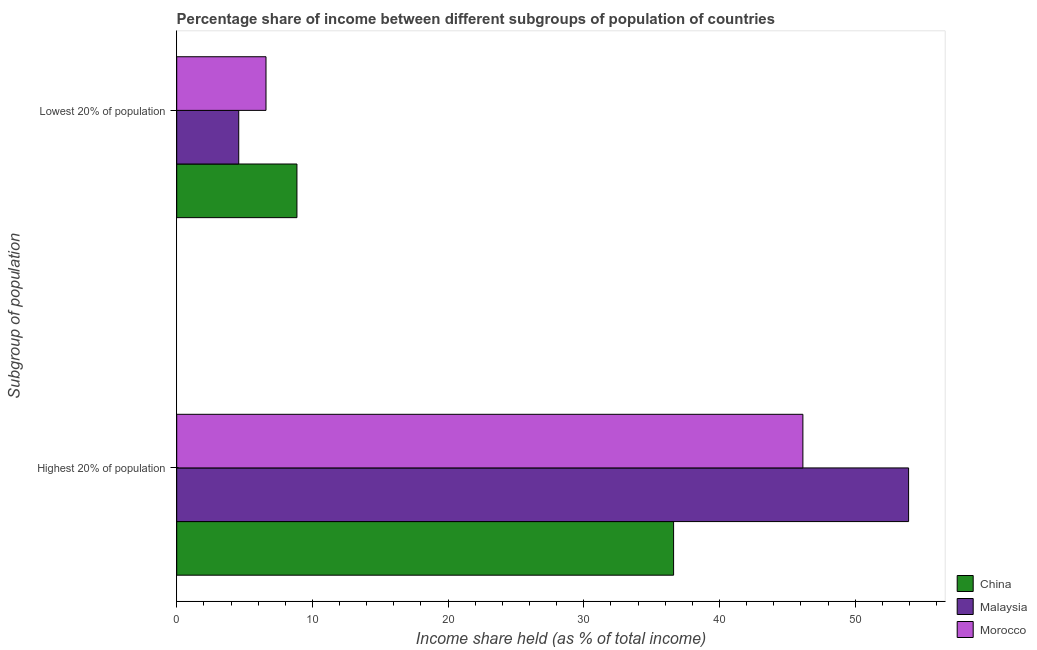Are the number of bars per tick equal to the number of legend labels?
Offer a very short reply. Yes. How many bars are there on the 1st tick from the bottom?
Give a very brief answer. 3. What is the label of the 2nd group of bars from the top?
Make the answer very short. Highest 20% of population. What is the income share held by lowest 20% of the population in China?
Offer a terse response. 8.86. Across all countries, what is the maximum income share held by lowest 20% of the population?
Ensure brevity in your answer.  8.86. Across all countries, what is the minimum income share held by lowest 20% of the population?
Your answer should be compact. 4.57. In which country was the income share held by highest 20% of the population maximum?
Provide a short and direct response. Malaysia. What is the total income share held by highest 20% of the population in the graph?
Ensure brevity in your answer.  136.71. What is the difference between the income share held by highest 20% of the population in Malaysia and that in China?
Keep it short and to the point. 17.32. What is the difference between the income share held by lowest 20% of the population in Malaysia and the income share held by highest 20% of the population in China?
Your answer should be compact. -32.05. What is the average income share held by highest 20% of the population per country?
Your answer should be very brief. 45.57. What is the difference between the income share held by lowest 20% of the population and income share held by highest 20% of the population in Malaysia?
Your answer should be compact. -49.37. In how many countries, is the income share held by lowest 20% of the population greater than 44 %?
Offer a terse response. 0. What is the ratio of the income share held by lowest 20% of the population in Morocco to that in Malaysia?
Provide a succinct answer. 1.44. Is the income share held by lowest 20% of the population in China less than that in Morocco?
Offer a terse response. No. In how many countries, is the income share held by lowest 20% of the population greater than the average income share held by lowest 20% of the population taken over all countries?
Ensure brevity in your answer.  1. What does the 2nd bar from the top in Lowest 20% of population represents?
Give a very brief answer. Malaysia. What does the 3rd bar from the bottom in Highest 20% of population represents?
Ensure brevity in your answer.  Morocco. How many bars are there?
Make the answer very short. 6. Are all the bars in the graph horizontal?
Ensure brevity in your answer.  Yes. How many countries are there in the graph?
Offer a very short reply. 3. Are the values on the major ticks of X-axis written in scientific E-notation?
Your answer should be compact. No. Does the graph contain grids?
Keep it short and to the point. No. What is the title of the graph?
Offer a very short reply. Percentage share of income between different subgroups of population of countries. Does "Grenada" appear as one of the legend labels in the graph?
Offer a very short reply. No. What is the label or title of the X-axis?
Provide a succinct answer. Income share held (as % of total income). What is the label or title of the Y-axis?
Keep it short and to the point. Subgroup of population. What is the Income share held (as % of total income) of China in Highest 20% of population?
Your response must be concise. 36.62. What is the Income share held (as % of total income) of Malaysia in Highest 20% of population?
Offer a very short reply. 53.94. What is the Income share held (as % of total income) in Morocco in Highest 20% of population?
Offer a very short reply. 46.15. What is the Income share held (as % of total income) of China in Lowest 20% of population?
Ensure brevity in your answer.  8.86. What is the Income share held (as % of total income) of Malaysia in Lowest 20% of population?
Provide a short and direct response. 4.57. What is the Income share held (as % of total income) in Morocco in Lowest 20% of population?
Your answer should be very brief. 6.58. Across all Subgroup of population, what is the maximum Income share held (as % of total income) of China?
Offer a very short reply. 36.62. Across all Subgroup of population, what is the maximum Income share held (as % of total income) in Malaysia?
Provide a short and direct response. 53.94. Across all Subgroup of population, what is the maximum Income share held (as % of total income) in Morocco?
Ensure brevity in your answer.  46.15. Across all Subgroup of population, what is the minimum Income share held (as % of total income) in China?
Your answer should be compact. 8.86. Across all Subgroup of population, what is the minimum Income share held (as % of total income) in Malaysia?
Your response must be concise. 4.57. Across all Subgroup of population, what is the minimum Income share held (as % of total income) of Morocco?
Provide a short and direct response. 6.58. What is the total Income share held (as % of total income) in China in the graph?
Provide a short and direct response. 45.48. What is the total Income share held (as % of total income) of Malaysia in the graph?
Your answer should be very brief. 58.51. What is the total Income share held (as % of total income) of Morocco in the graph?
Provide a short and direct response. 52.73. What is the difference between the Income share held (as % of total income) in China in Highest 20% of population and that in Lowest 20% of population?
Provide a succinct answer. 27.76. What is the difference between the Income share held (as % of total income) in Malaysia in Highest 20% of population and that in Lowest 20% of population?
Provide a succinct answer. 49.37. What is the difference between the Income share held (as % of total income) in Morocco in Highest 20% of population and that in Lowest 20% of population?
Give a very brief answer. 39.57. What is the difference between the Income share held (as % of total income) of China in Highest 20% of population and the Income share held (as % of total income) of Malaysia in Lowest 20% of population?
Your response must be concise. 32.05. What is the difference between the Income share held (as % of total income) of China in Highest 20% of population and the Income share held (as % of total income) of Morocco in Lowest 20% of population?
Ensure brevity in your answer.  30.04. What is the difference between the Income share held (as % of total income) of Malaysia in Highest 20% of population and the Income share held (as % of total income) of Morocco in Lowest 20% of population?
Offer a terse response. 47.36. What is the average Income share held (as % of total income) in China per Subgroup of population?
Keep it short and to the point. 22.74. What is the average Income share held (as % of total income) in Malaysia per Subgroup of population?
Offer a terse response. 29.25. What is the average Income share held (as % of total income) of Morocco per Subgroup of population?
Offer a terse response. 26.36. What is the difference between the Income share held (as % of total income) in China and Income share held (as % of total income) in Malaysia in Highest 20% of population?
Your response must be concise. -17.32. What is the difference between the Income share held (as % of total income) in China and Income share held (as % of total income) in Morocco in Highest 20% of population?
Offer a very short reply. -9.53. What is the difference between the Income share held (as % of total income) in Malaysia and Income share held (as % of total income) in Morocco in Highest 20% of population?
Ensure brevity in your answer.  7.79. What is the difference between the Income share held (as % of total income) in China and Income share held (as % of total income) in Malaysia in Lowest 20% of population?
Your answer should be compact. 4.29. What is the difference between the Income share held (as % of total income) in China and Income share held (as % of total income) in Morocco in Lowest 20% of population?
Your answer should be very brief. 2.28. What is the difference between the Income share held (as % of total income) in Malaysia and Income share held (as % of total income) in Morocco in Lowest 20% of population?
Your answer should be compact. -2.01. What is the ratio of the Income share held (as % of total income) in China in Highest 20% of population to that in Lowest 20% of population?
Provide a short and direct response. 4.13. What is the ratio of the Income share held (as % of total income) of Malaysia in Highest 20% of population to that in Lowest 20% of population?
Make the answer very short. 11.8. What is the ratio of the Income share held (as % of total income) of Morocco in Highest 20% of population to that in Lowest 20% of population?
Ensure brevity in your answer.  7.01. What is the difference between the highest and the second highest Income share held (as % of total income) in China?
Offer a terse response. 27.76. What is the difference between the highest and the second highest Income share held (as % of total income) of Malaysia?
Keep it short and to the point. 49.37. What is the difference between the highest and the second highest Income share held (as % of total income) in Morocco?
Give a very brief answer. 39.57. What is the difference between the highest and the lowest Income share held (as % of total income) of China?
Offer a terse response. 27.76. What is the difference between the highest and the lowest Income share held (as % of total income) of Malaysia?
Keep it short and to the point. 49.37. What is the difference between the highest and the lowest Income share held (as % of total income) in Morocco?
Your answer should be compact. 39.57. 